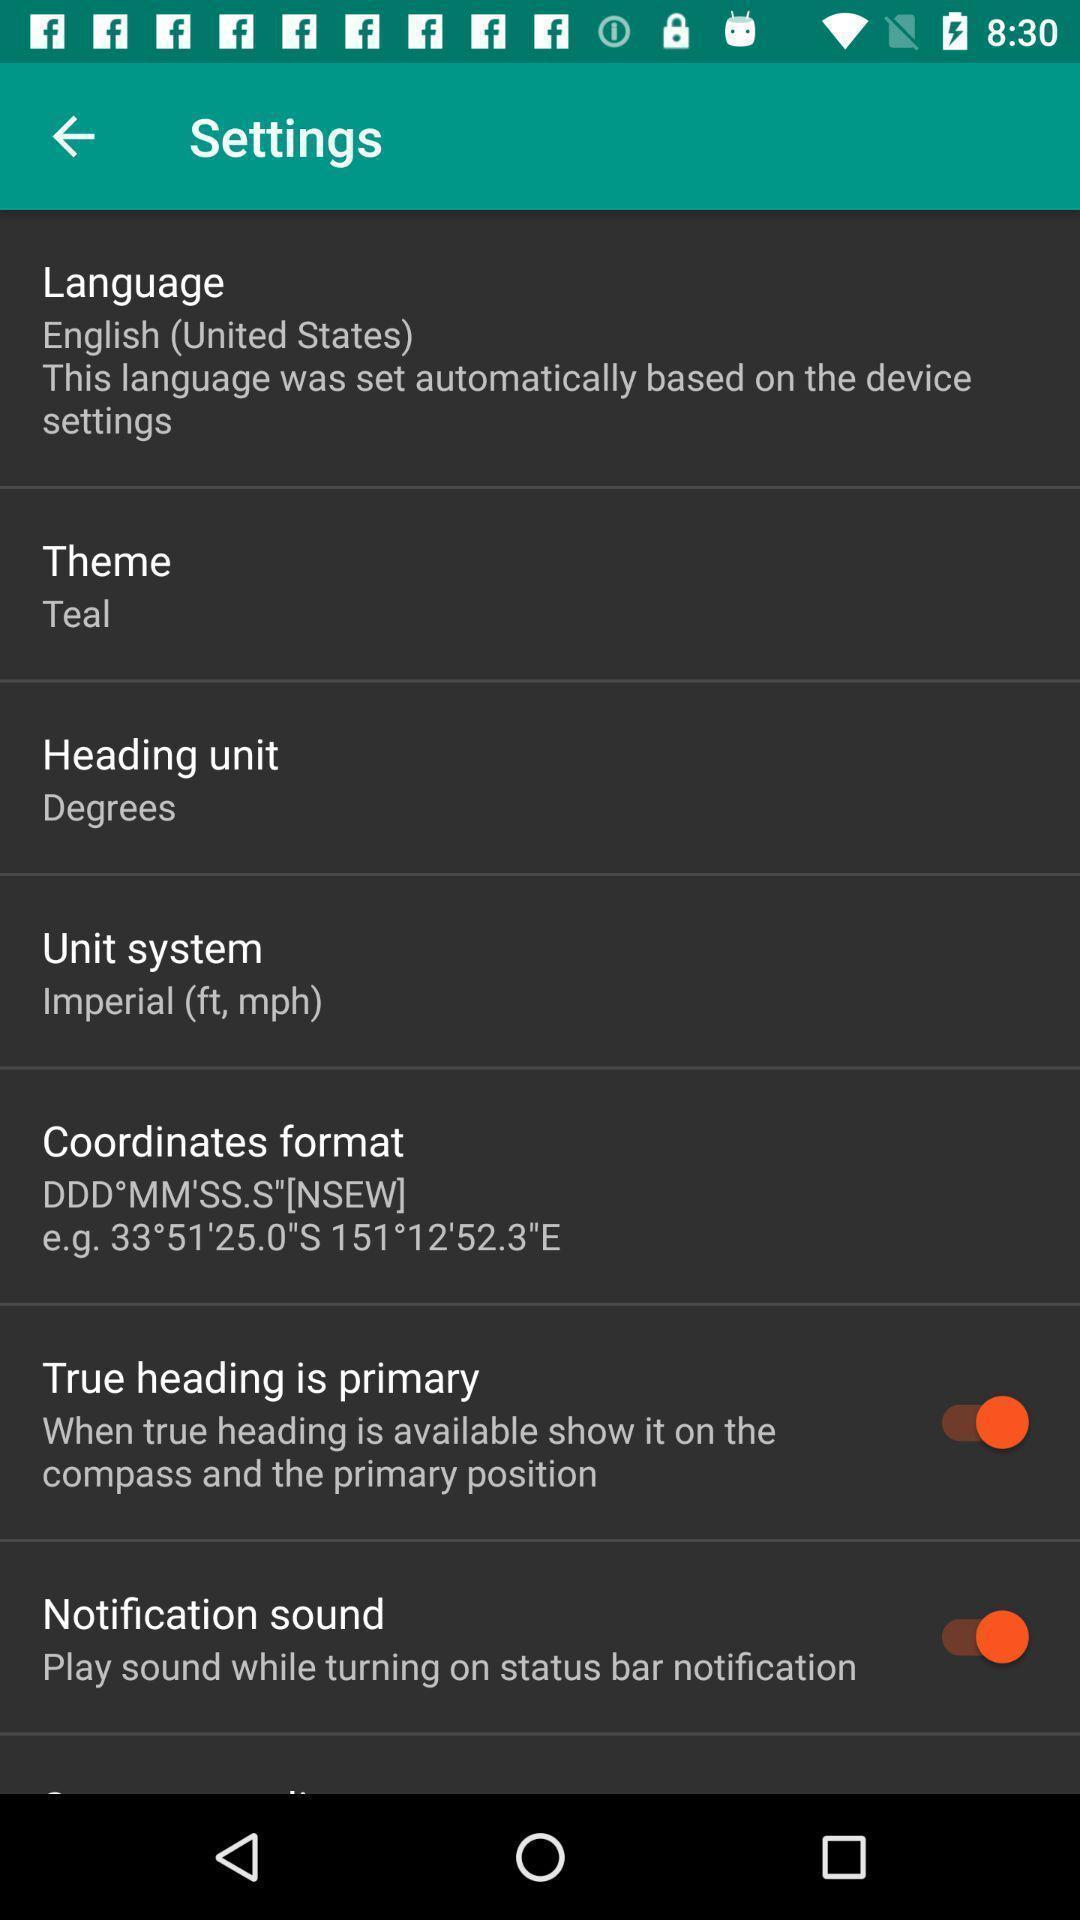Describe this image in words. Settings page. 